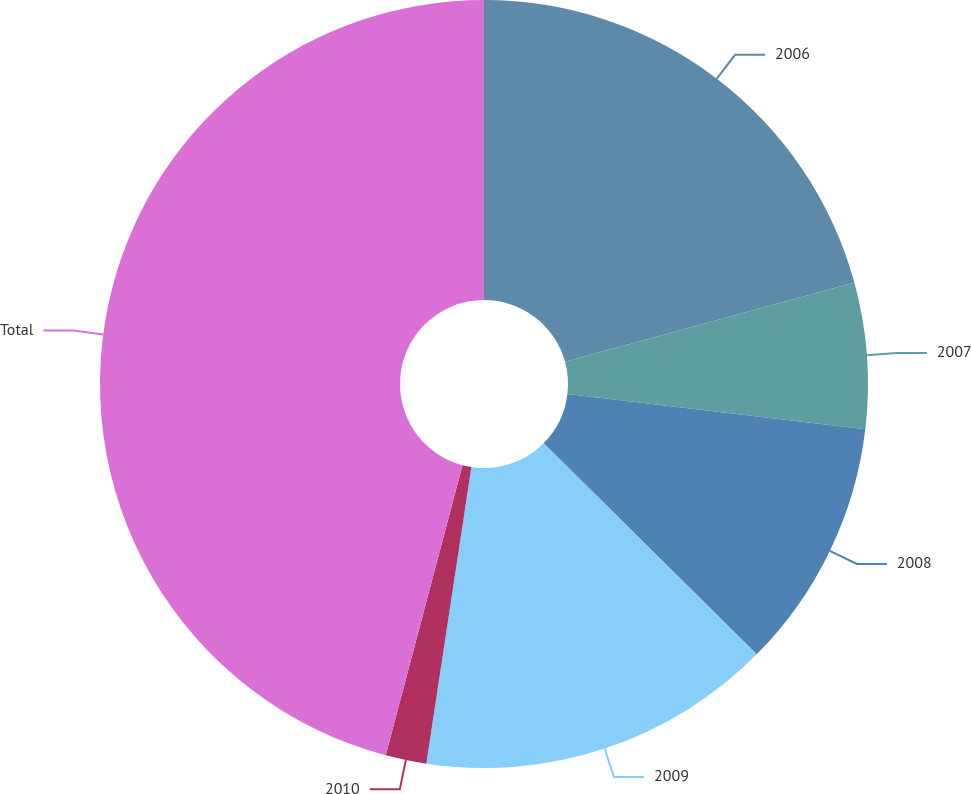<chart> <loc_0><loc_0><loc_500><loc_500><pie_chart><fcel>2006<fcel>2007<fcel>2008<fcel>2009<fcel>2010<fcel>Total<nl><fcel>20.74%<fcel>6.14%<fcel>10.55%<fcel>14.97%<fcel>1.72%<fcel>45.88%<nl></chart> 